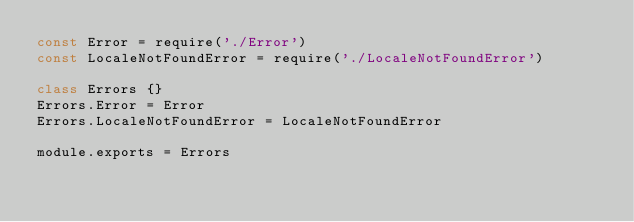Convert code to text. <code><loc_0><loc_0><loc_500><loc_500><_JavaScript_>const Error = require('./Error')
const LocaleNotFoundError = require('./LocaleNotFoundError')

class Errors {}
Errors.Error = Error
Errors.LocaleNotFoundError = LocaleNotFoundError

module.exports = Errors
</code> 